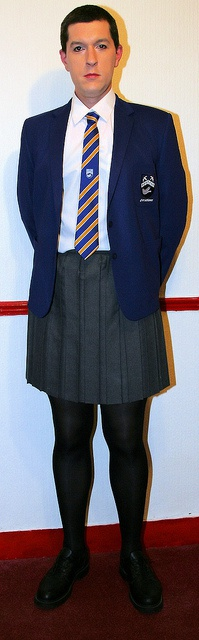Describe the objects in this image and their specific colors. I can see people in beige, black, navy, lavender, and tan tones and tie in beige, darkblue, navy, and orange tones in this image. 